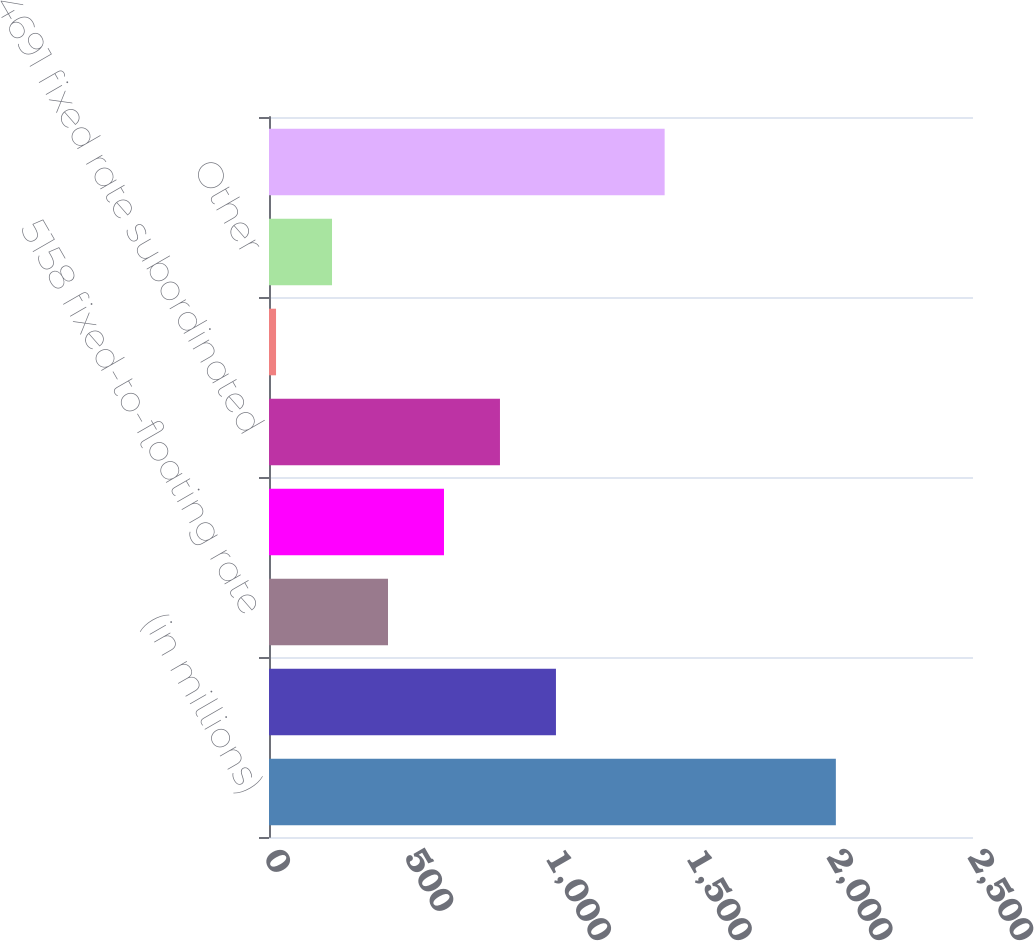Convert chart. <chart><loc_0><loc_0><loc_500><loc_500><bar_chart><fcel>(in millions)<fcel>4150 fixed rate subordinated<fcel>5158 fixed-to-floating rate<fcel>4771 fixed rate subordinated<fcel>4691 fixed rate subordinated<fcel>Federal Home Loan advances due<fcel>Other<fcel>Total long-term borrowed funds<nl><fcel>2013<fcel>1019<fcel>422.6<fcel>621.4<fcel>820.2<fcel>25<fcel>223.8<fcel>1405<nl></chart> 